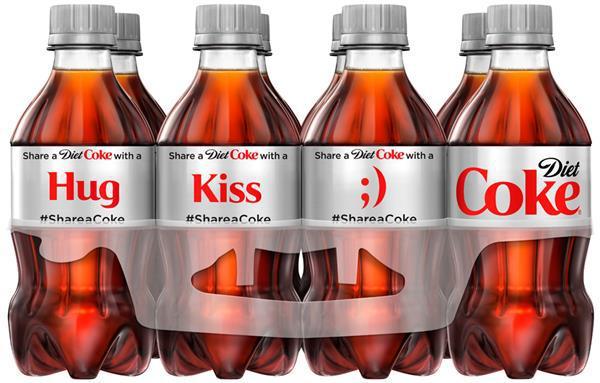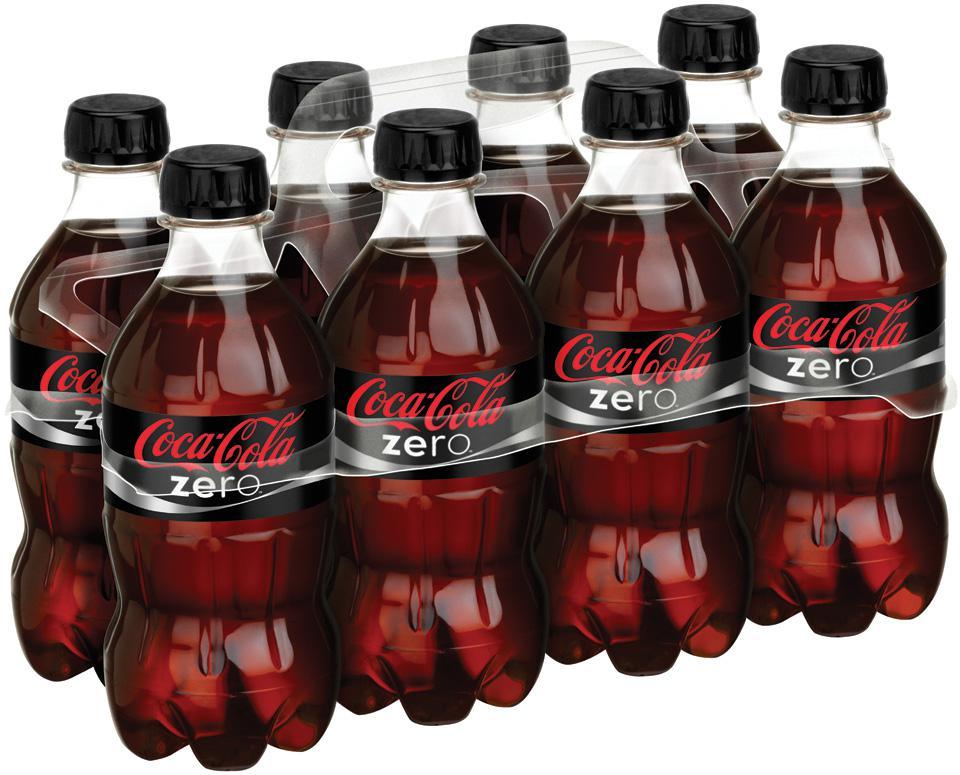The first image is the image on the left, the second image is the image on the right. Examine the images to the left and right. Is the description "There are only eight bottles of diet coke in the image to the right; there are no extra, loose bottles." accurate? Answer yes or no. No. The first image is the image on the left, the second image is the image on the right. Evaluate the accuracy of this statement regarding the images: "Each image shows a multipack of eight soda bottles with non-black caps and no box packaging, and the labels of the bottles in the right and left images are nearly identical.". Is it true? Answer yes or no. No. 